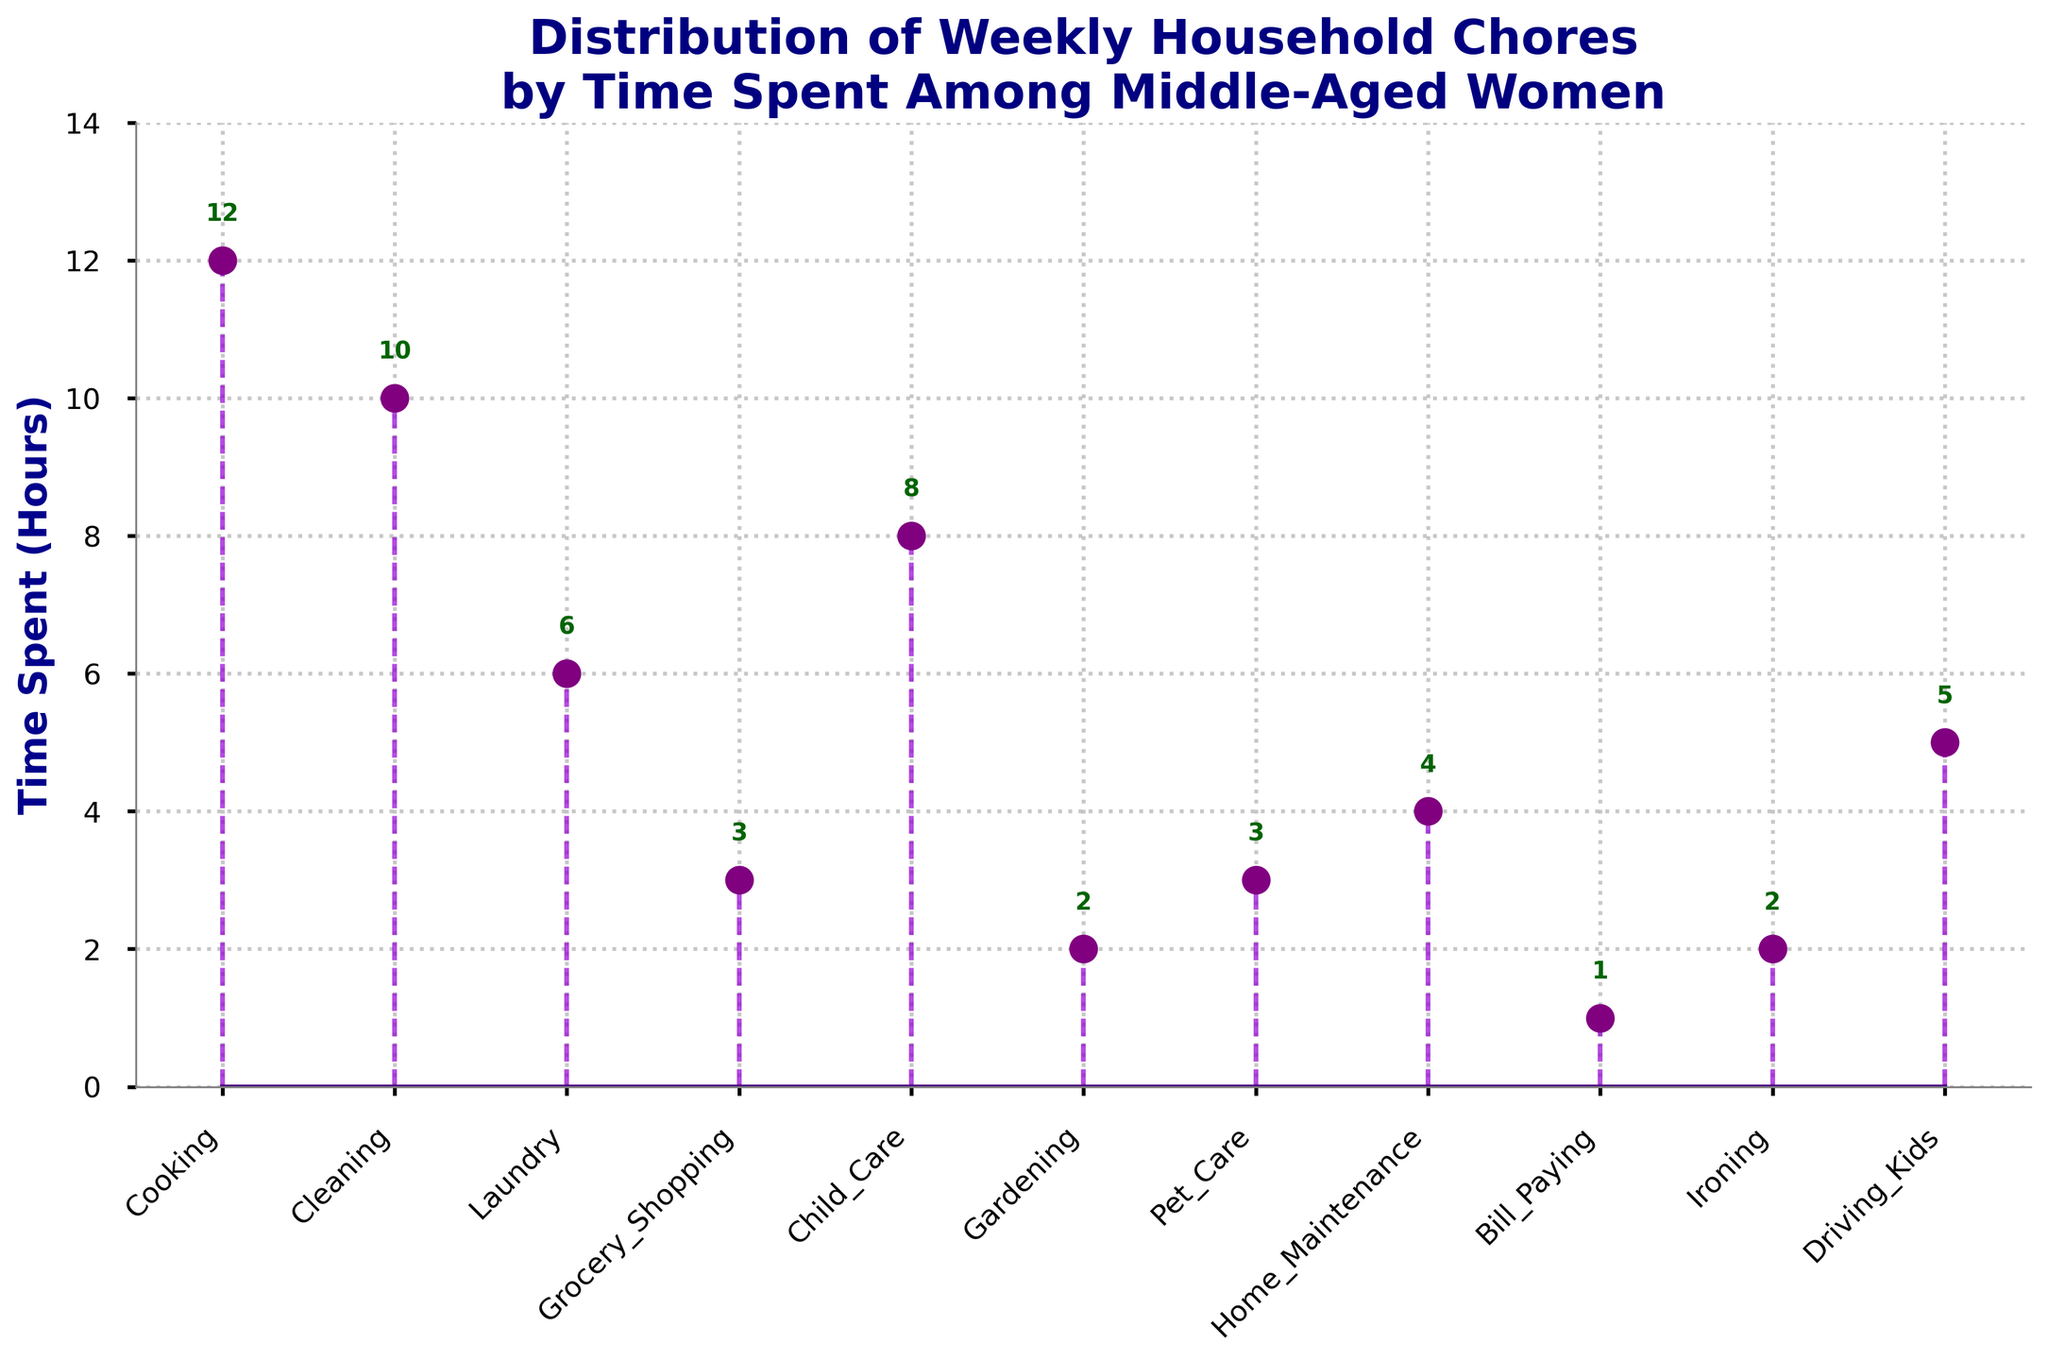What's the title of the figure? Look at the text at the top of the figure, which is usually the title. It reads "Distribution of Weekly Household Chores by Time Spent Among Middle-Aged Women".
Answer: Distribution of Weekly Household Chores by Time Spent Among Middle-Aged Women What chore takes the most time? Look for the highest point in the stem plot. The stem corresponding to "Cooking" reaches the highest point at 12 hours.
Answer: Cooking How many hours are spent on cleaning each week? Identify the stem labeled "Cleaning". The height of this stem indicates the value, which is 10 hours.
Answer: 10 hours Which chores take 3 hours each? Find the stems that reach the 3-hour mark. These are "Grocery Shopping" and "Pet Care".
Answer: Grocery Shopping and Pet Care What is the combined time spent on Grocery Shopping and Pet Care? Identify the times for "Grocery Shopping" (3 hours) and "Pet Care" (3 hours), then sum them up: 3 + 3 = 6.
Answer: 6 hours How much more time is spent on Child Care than on Home Maintenance? Compare the times for "Child Care" (8 hours) and "Home Maintenance" (4 hours). The difference is 8 - 4 = 4.
Answer: 4 hours What is the average time spent on Cooking, Cleaning, and Laundry? Identify the times: Cooking (12), Cleaning (10), Laundry (6). Sum: 12 + 10 + 6 = 28. Average: 28 / 3 = 9.33.
Answer: 9.33 hours What is the total time spent on all household chores? Sum up all the times: 12 (Cooking) + 10 (Cleaning) + 6 (Laundry) + 3 (Grocery Shopping) + 8 (Child Care) + 2 (Gardening) + 3 (Pet Care) + 4 (Home Maintenance) + 1 (Bill Paying) + 2 (Ironing) + 5 (Driving Kids) = 56.
Answer: 56 hours Which has more hours, Gardening or Ironing? Compare the times: Gardening has 2 hours and Ironing has 2 hours. They are equal.
Answer: They are equal What chores take less time than Driving Kids? Identify the times for chores and compare them to the 5 hours for Driving Kids. These are: Bill Paying (1), Gardening (2), Ironing (2), Grocery Shopping (3), Pet Care (3).
Answer: Bill Paying, Gardening, Ironing, Grocery Shopping, Pet Care 